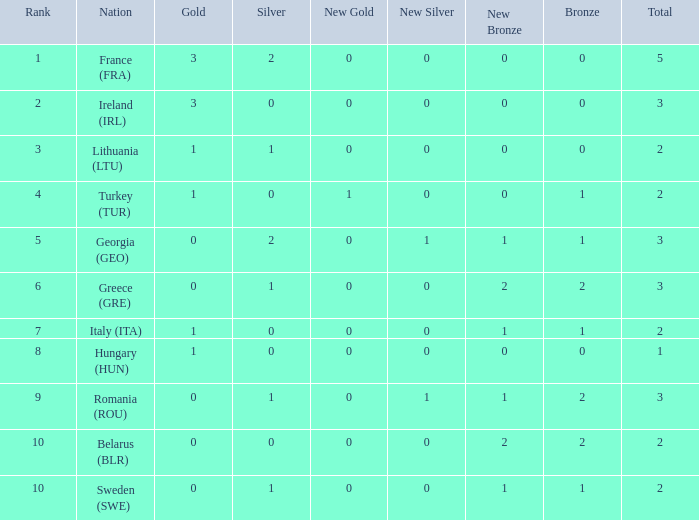What's the total when the gold is less than 0 and silver is less than 1? None. 